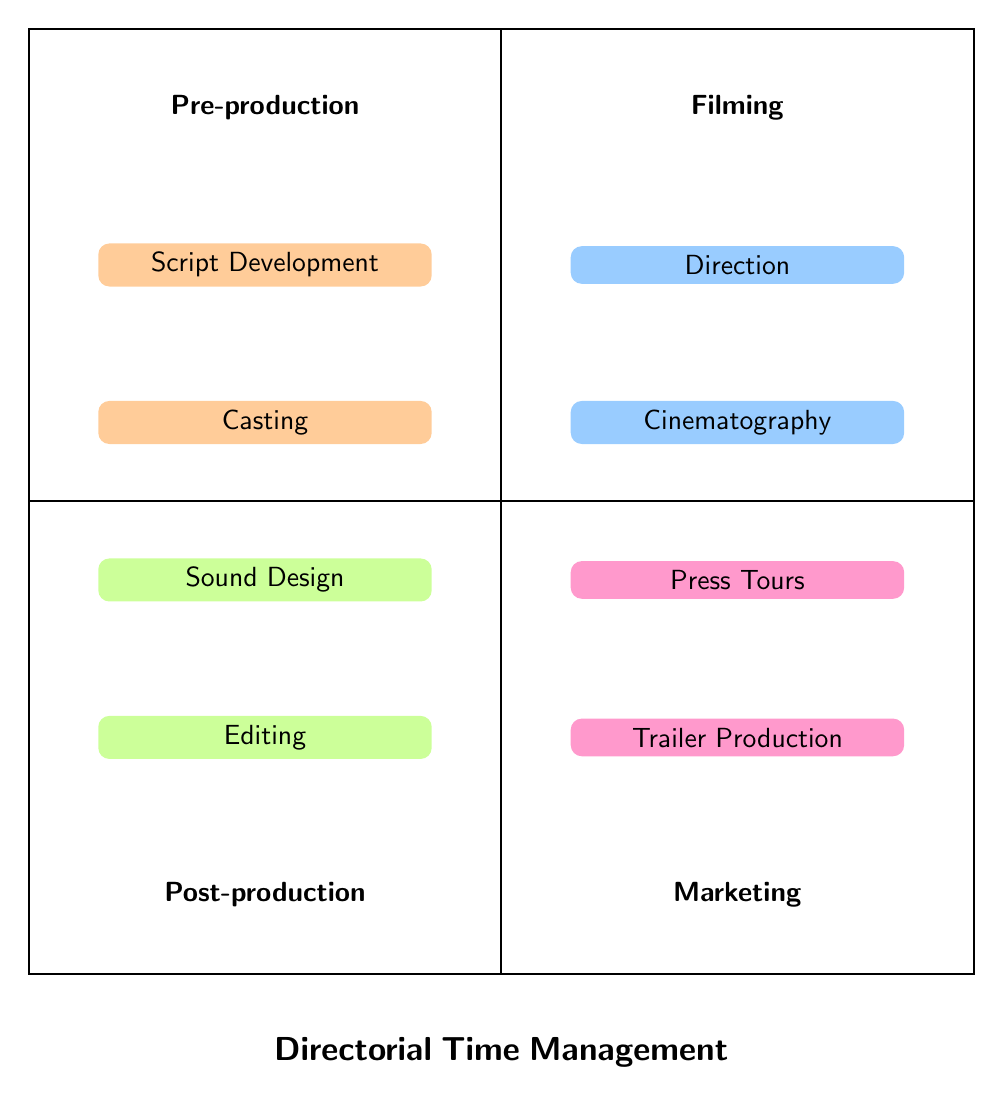What is the main focus of the top left quadrant? The top left quadrant represents "Pre-production," indicating activities that happen before filming begins.
Answer: Pre-production How many activities are listed under Filming? There are four activities listed under the Filming quadrant: Direction, Cinematography, Scheduling, and On-Set Problem Solving, which can be counted directly from the diagram.
Answer: 4 What is the first activity listed in Post-production? The first activity under Post-production is "Editing," which is the top activity in that quadrant as seen in the diagram.
Answer: Editing Which quadrant includes "Social Media Campaigns"? "Social Media Campaigns" is found in the Marketing quadrant, as it addresses promotional strategies post-filming.
Answer: Marketing How many quadrants are there in total? There are four quadrants in this diagram: Pre-production, Filming, Post-production, and Marketing, which can be counted from the layout.
Answer: 4 What are the two activities listed under Marketing? The two activities in the Marketing quadrant are "Trailer Production" and "Press Tours," which can be read directly from the diagram.
Answer: Trailer Production, Press Tours Which activity is related to managing the daily shooting schedule? "Scheduling" is the activity concerned with managing the daily shooting schedule and is explicitly mentioned under the Filming quadrant.
Answer: Scheduling What is the primary goal of the activities in the Up quadrant? The primary goal of the activities in the Up quadrant (Pre-production and Filming) is to prepare and execute the filming process, highlighting foundational work before release.
Answer: Preparation What does "Sound Design" involve? "Sound Design" involves adding and mixing sound effects and music, which is explicitly detailed in the Post-production quadrant.
Answer: Adding and mixing sound effects and music 